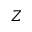<formula> <loc_0><loc_0><loc_500><loc_500>Z</formula> 